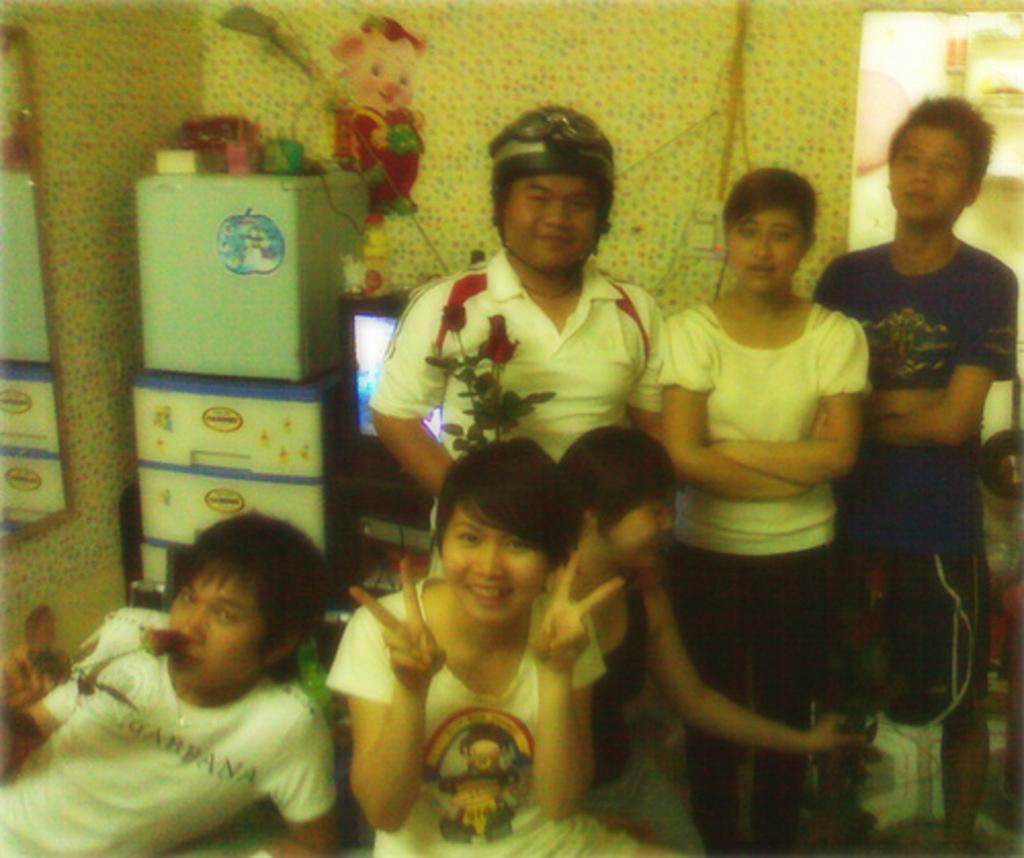How many people can be seen in the image? There are many persons sitting and standing in the image. What can be seen in the background of the image? There is a wall, a refrigerator, cupboards, a television, wires, stickers, a mirror, and a door in the background of the image. What type of fear can be seen on the faces of the people in the image? There is no indication of fear on the faces of the people in the image. Can you describe the cellar visible in the image? There is no cellar present in the image. 